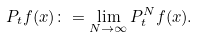Convert formula to latex. <formula><loc_0><loc_0><loc_500><loc_500>P _ { t } f ( x ) \colon = \lim _ { N \rightarrow \infty } P ^ { N } _ { t } f ( x ) .</formula> 